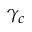<formula> <loc_0><loc_0><loc_500><loc_500>\gamma _ { c }</formula> 